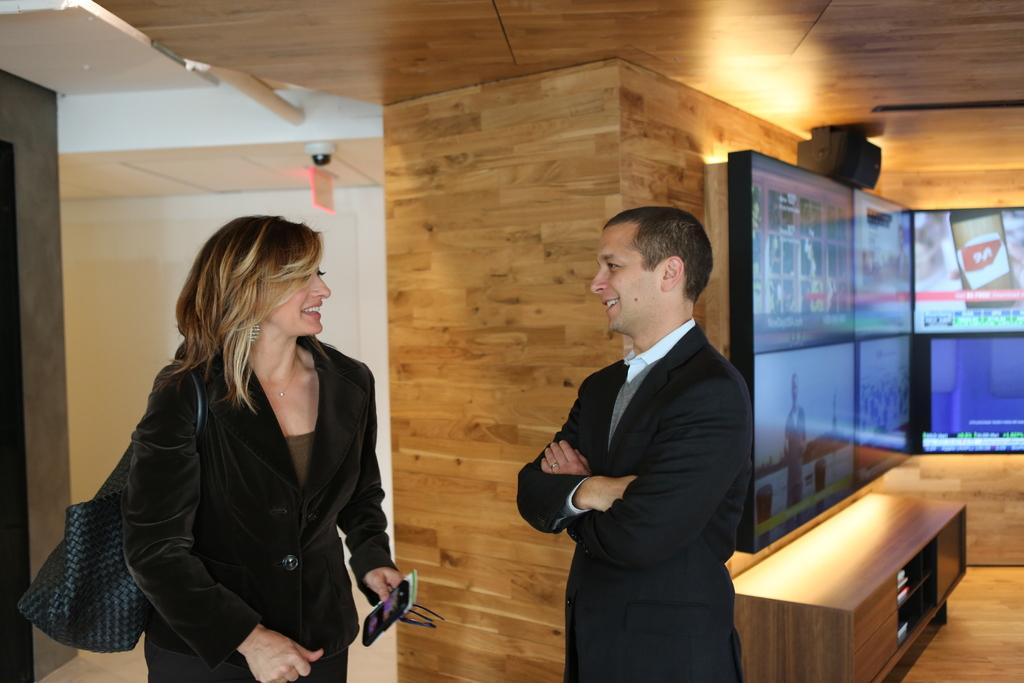Who are the people in the image? There is a woman and a man in the image. What are the positions of the woman and the man in the image? Both the woman and the man are standing. What is the woman holding in the image? The woman is carrying a handbag. What expressions do the woman and the man have in the image? The woman and the man are both smiling. How many stars can be seen in the image? There are no stars visible in the image. What type of cloud is present in the image? There is no cloud present in the image. 